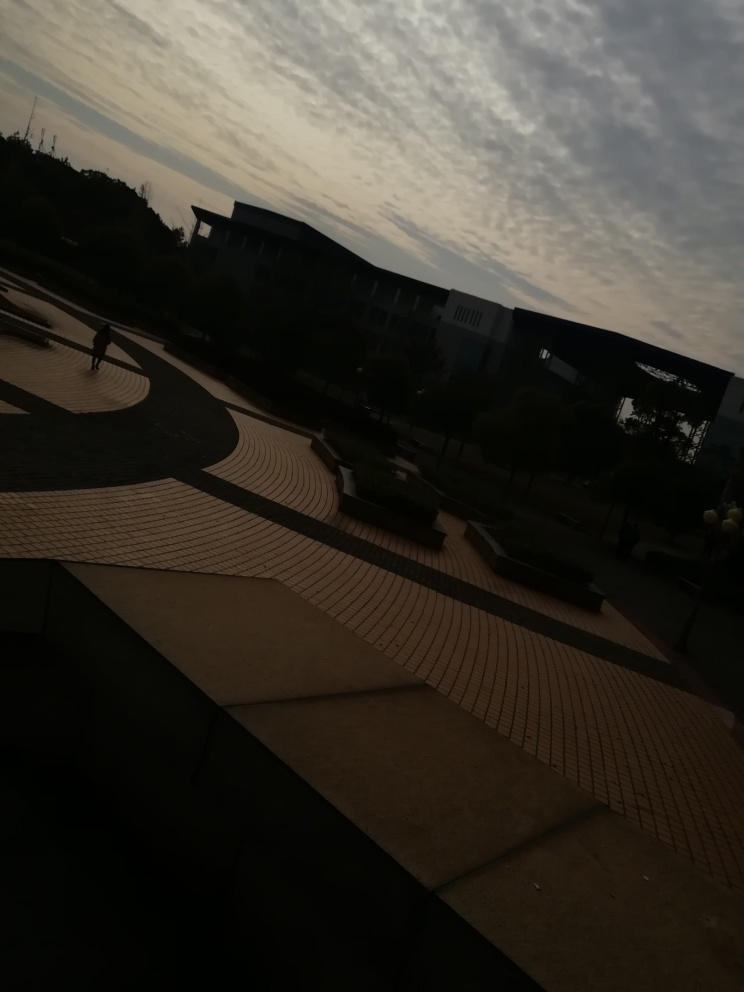What time of day does this photo look like it was taken? The photo appears to have been taken around dusk or dawn, as the sky is illuminated with soft light, but the presence of shadows and low light levels suggest the sun is low on the horizon. 